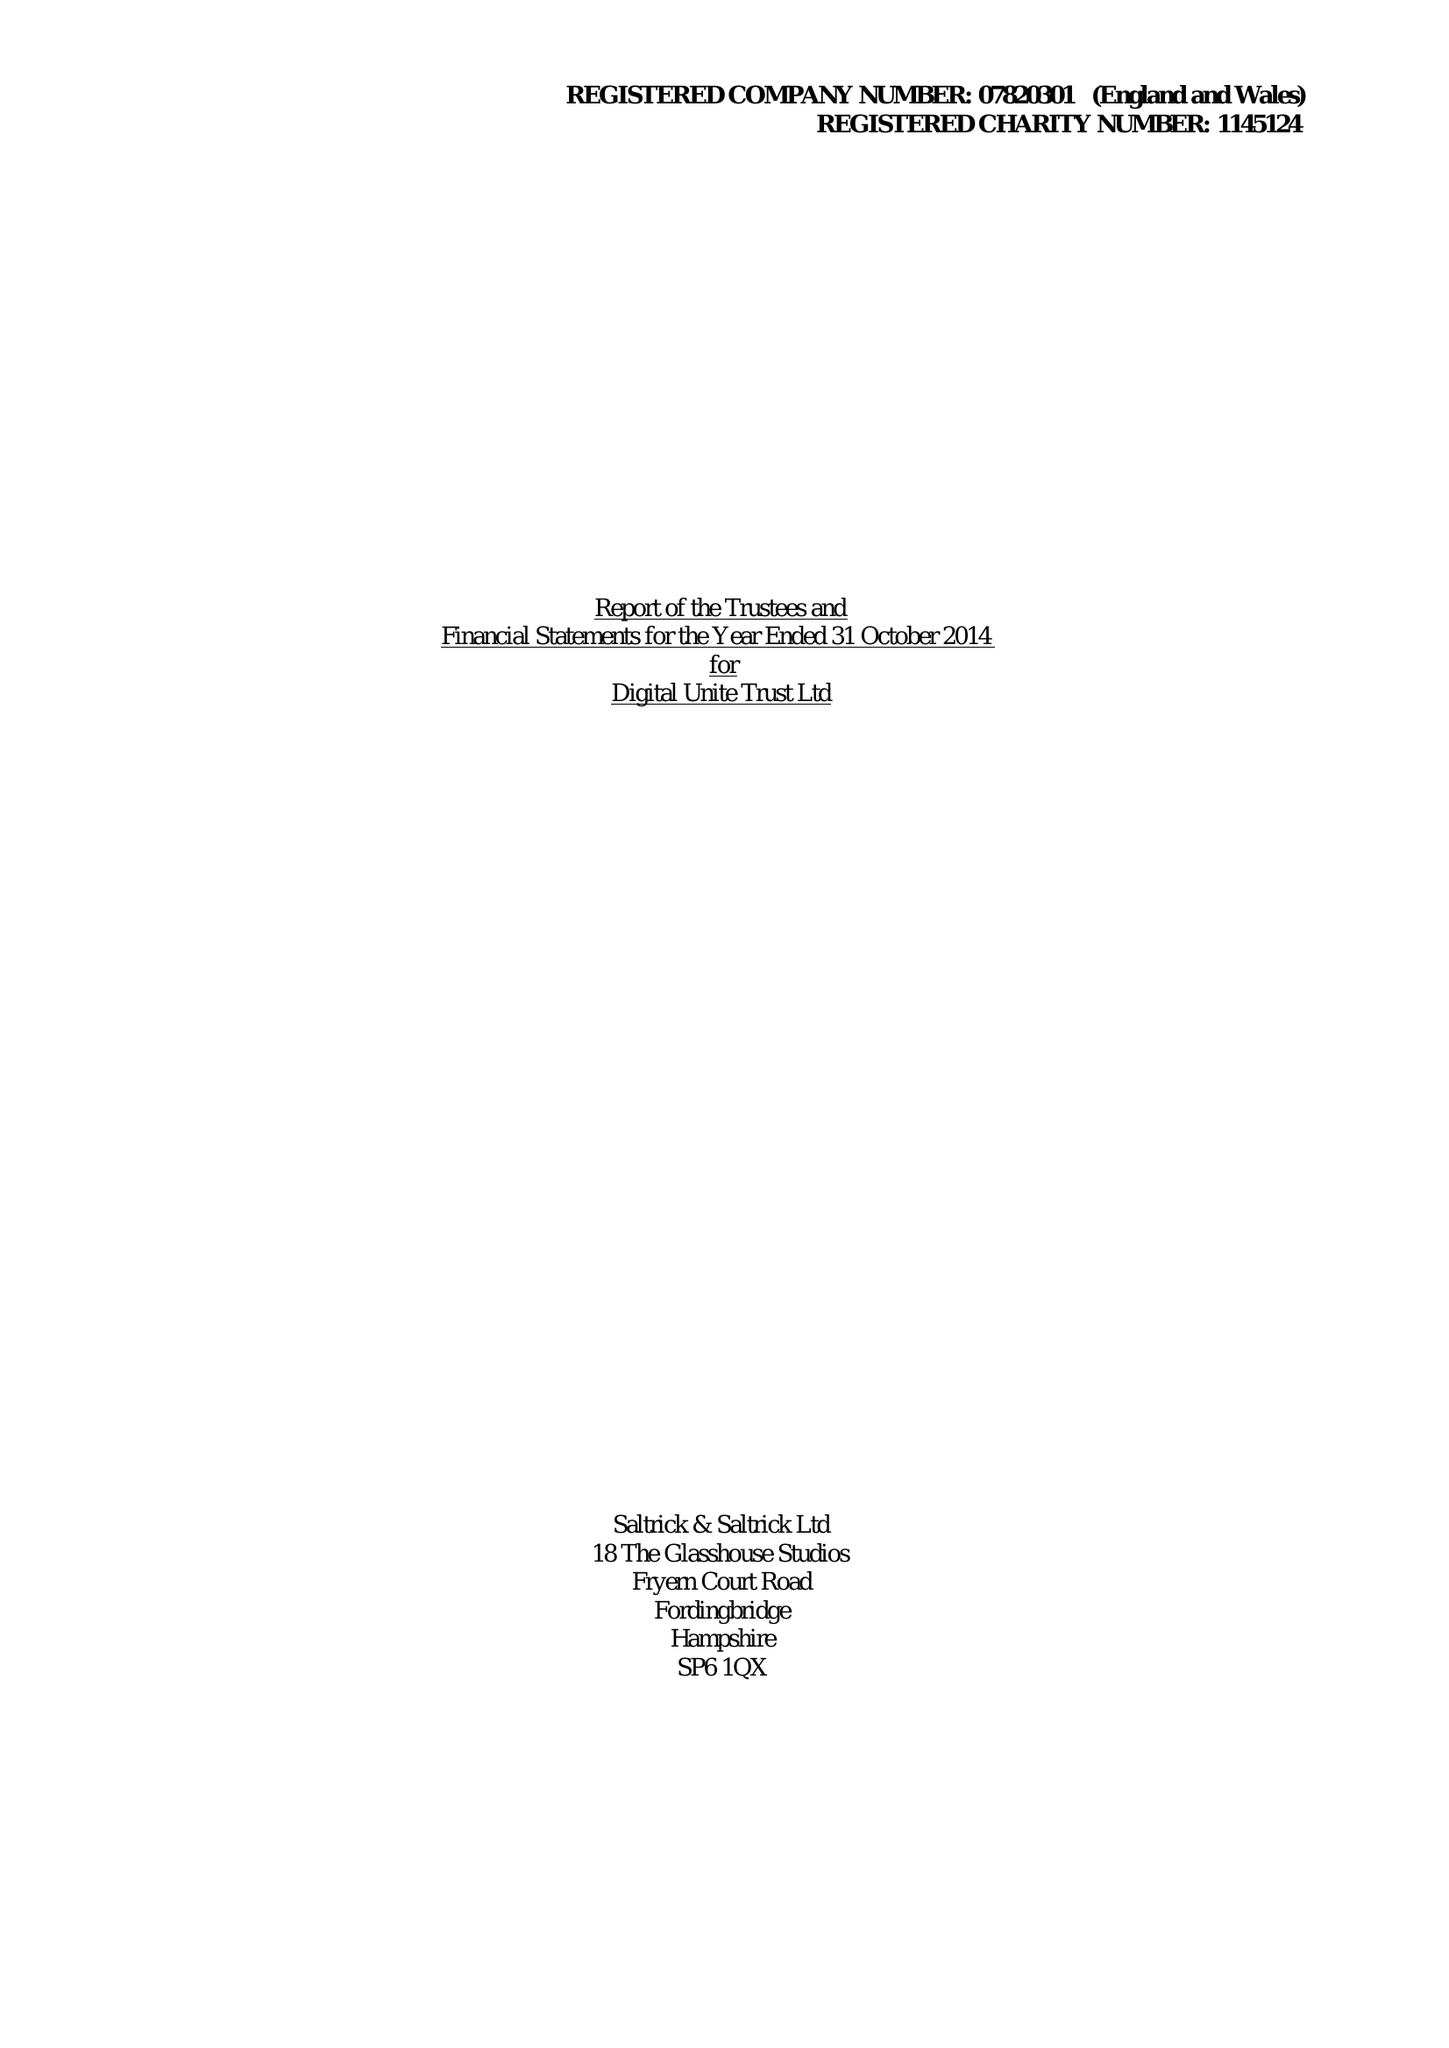What is the value for the spending_annually_in_british_pounds?
Answer the question using a single word or phrase. 82106.00 